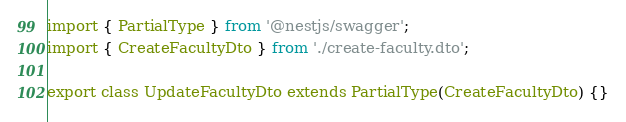Convert code to text. <code><loc_0><loc_0><loc_500><loc_500><_TypeScript_>import { PartialType } from '@nestjs/swagger';
import { CreateFacultyDto } from './create-faculty.dto';

export class UpdateFacultyDto extends PartialType(CreateFacultyDto) {}
</code> 